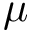Convert formula to latex. <formula><loc_0><loc_0><loc_500><loc_500>\mu</formula> 